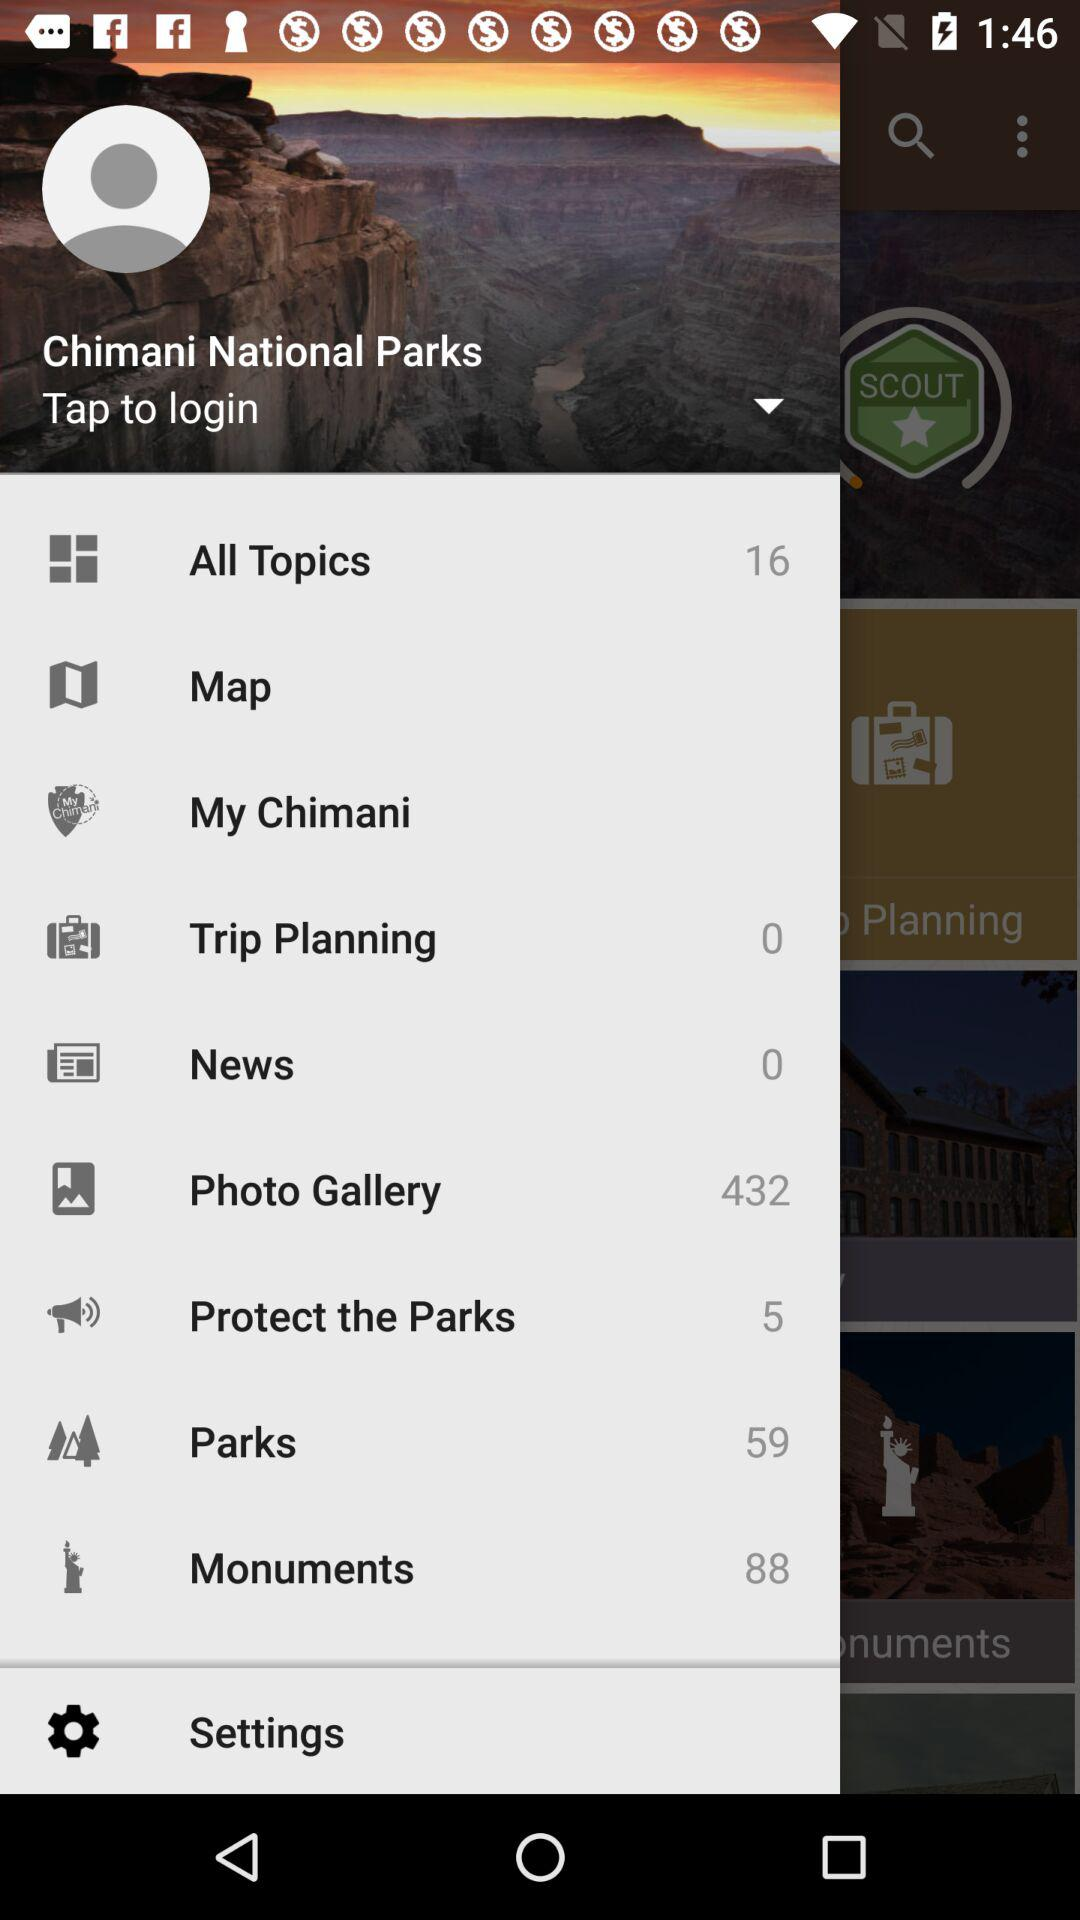What is the number of topics present in "All Topics"? The total number of topics is 16. 